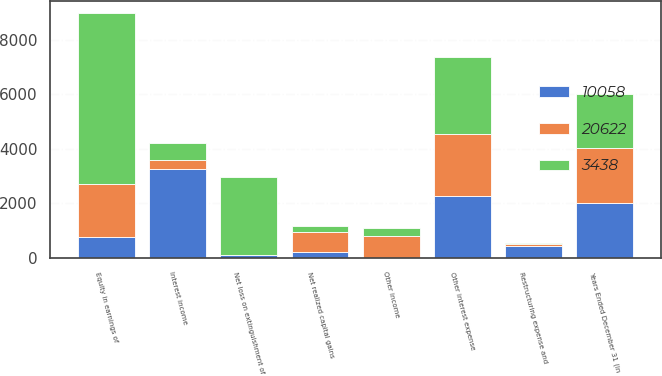<chart> <loc_0><loc_0><loc_500><loc_500><stacked_bar_chart><ecel><fcel>Years Ended December 31 (in<fcel>Equity in earnings of<fcel>Interest income<fcel>Net realized capital gains<fcel>Other income<fcel>Other interest expense<fcel>Restructuring expense and<fcel>Net loss on extinguishment of<nl><fcel>20622<fcel>2012<fcel>1970<fcel>358<fcel>747<fcel>806<fcel>2257<fcel>47<fcel>9<nl><fcel>3438<fcel>2011<fcel>6260<fcel>596<fcel>213<fcel>279<fcel>2845<fcel>36<fcel>2847<nl><fcel>10058<fcel>2010<fcel>747<fcel>3249<fcel>209<fcel>6<fcel>2279<fcel>451<fcel>104<nl></chart> 